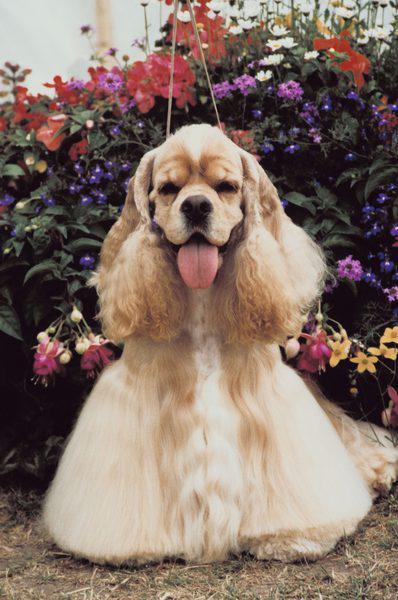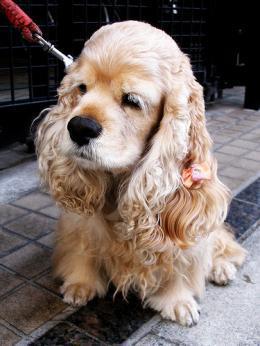The first image is the image on the left, the second image is the image on the right. Given the left and right images, does the statement "One image shows three dogs sitting in a row." hold true? Answer yes or no. No. 